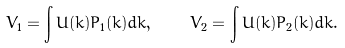<formula> <loc_0><loc_0><loc_500><loc_500>\bar { V } _ { 1 } = \int U ( { k } ) P _ { 1 } ( { k } ) d { k } , \quad \bar { V } _ { 2 } = \int U ( { k } ) P _ { 2 } ( { k } ) d { k } .</formula> 